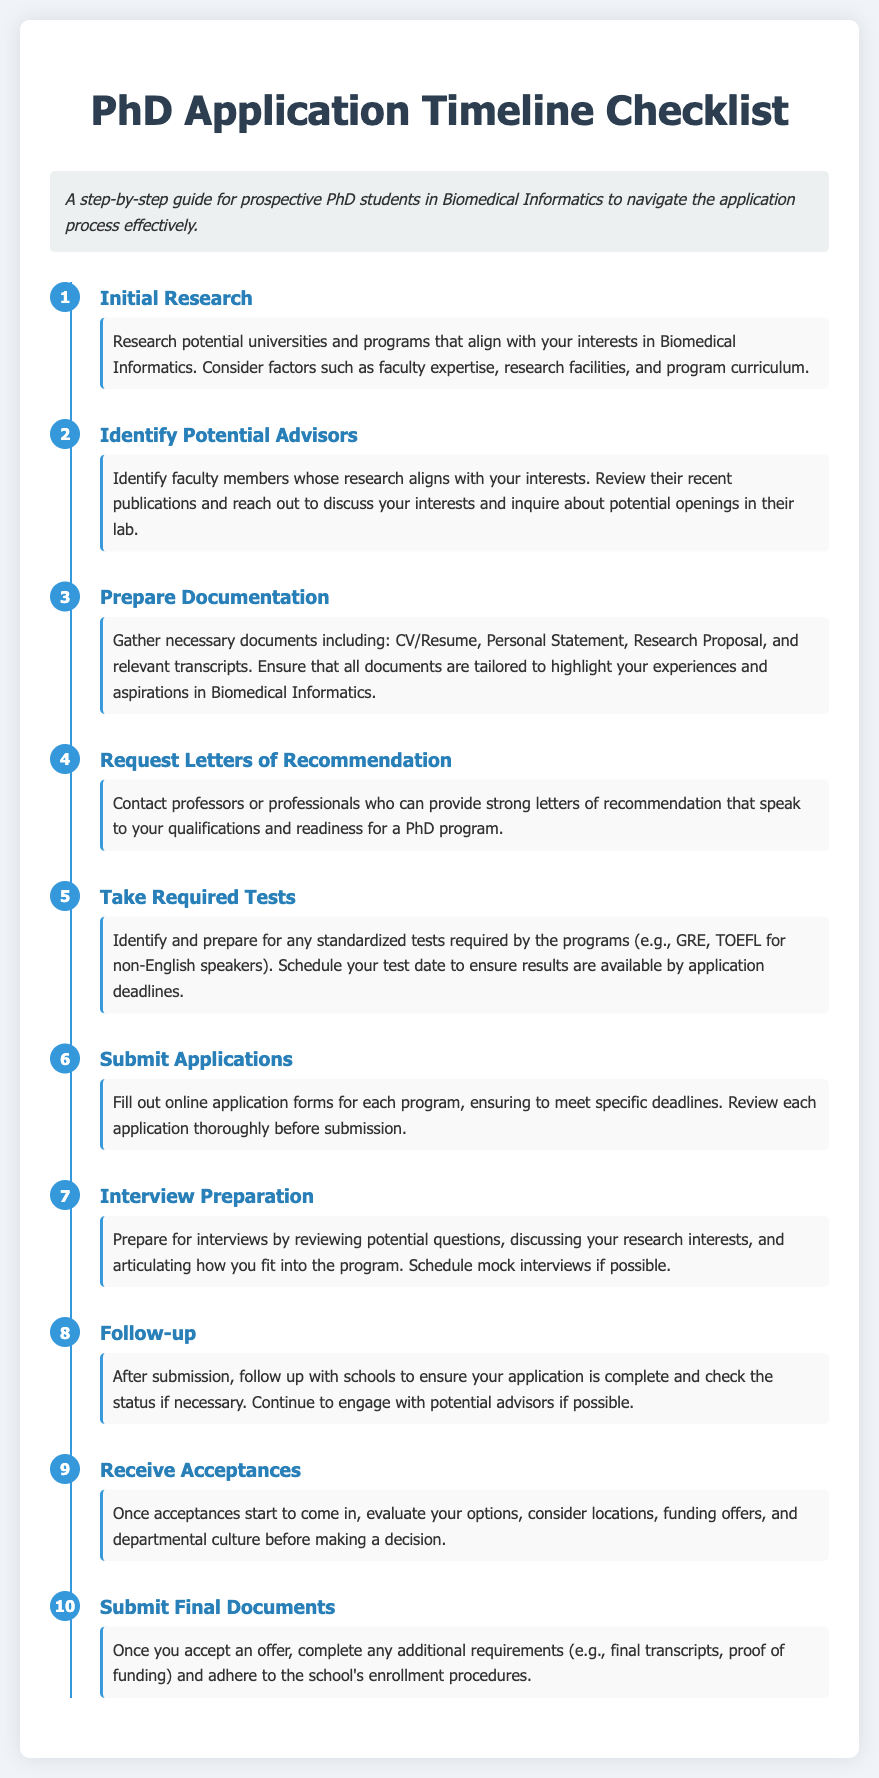What is the first step in the application timeline? The first step in the timeline is to conduct initial research on potential universities and programs.
Answer: Initial Research How many steps are included in the application timeline? The document outlines a total of ten steps in the application process.
Answer: 10 What should you prepare to submit with your application? You should prepare a CV/Resume, Personal Statement, Research Proposal, and relevant transcripts.
Answer: CV/Resume, Personal Statement, Research Proposal, transcripts Which step involves reaching out to faculty members? The step that involves reaching out to faculty members is the one where you identify potential advisors.
Answer: Identify Potential Advisors What is the primary focus of the "Follow-up" step? The primary focus is to ensure your application is complete and to check the status if necessary.
Answer: Ensure application is complete What is required before submitting applications? You need to review each application thoroughly before submission.
Answer: Review applications Which step mentions taking standardized tests? The step that mentions taking standardized tests is "Take Required Tests."
Answer: Take Required Tests What should you do after receiving acceptances? After receiving acceptances, evaluate your options considering various factors like funding offers.
Answer: Evaluate options What is the final step in the checklist? The final step in the checklist refers to submitting final documents after accepting an offer.
Answer: Submit Final Documents What kind of preparation should be done for interviews? Preparation for interviews involves reviewing potential questions and scheduling mock interviews if possible.
Answer: Review questions and schedule mock interviews 